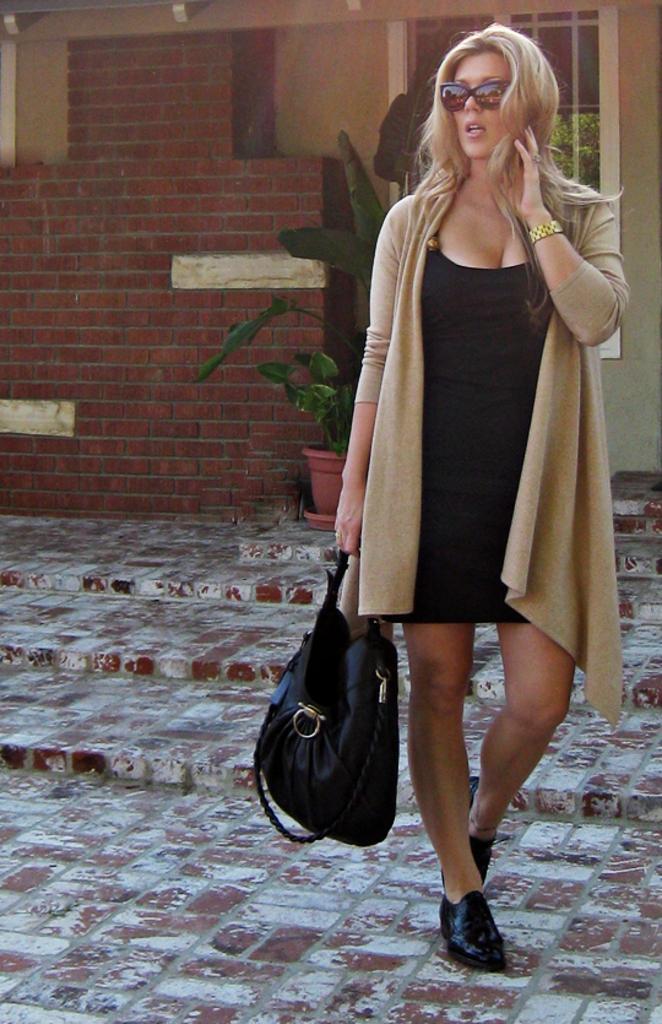How would you summarize this image in a sentence or two? In the picture a woman is walking by carrying a bag with her there is a house plant near to her there is also a building near to her. 